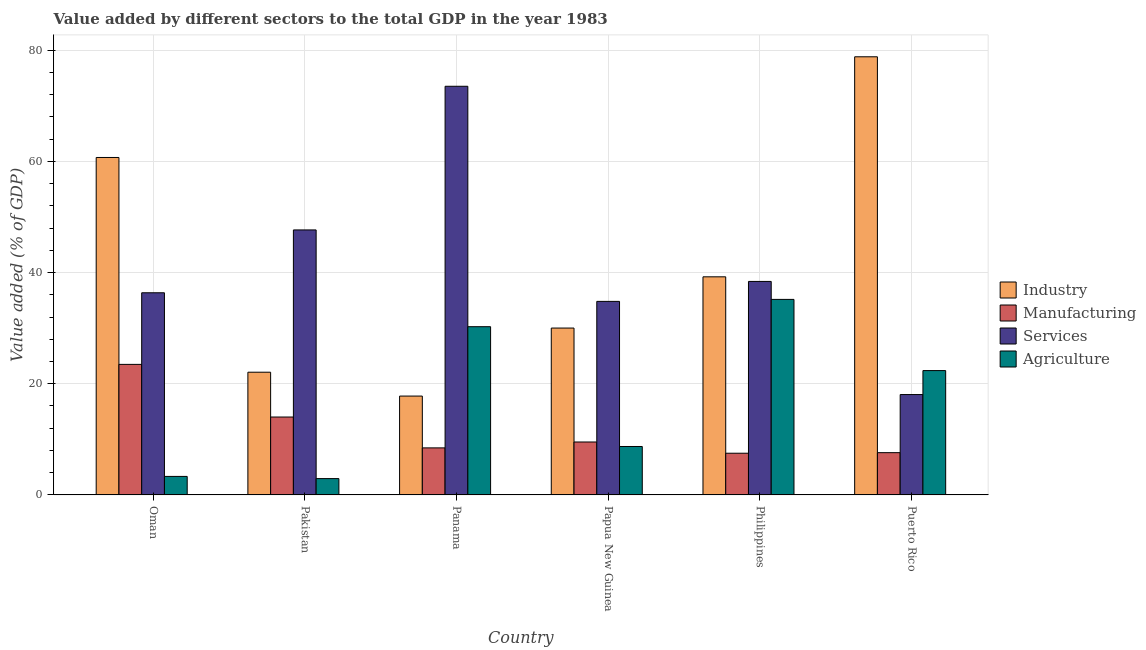How many different coloured bars are there?
Keep it short and to the point. 4. How many groups of bars are there?
Your answer should be very brief. 6. Are the number of bars per tick equal to the number of legend labels?
Your answer should be very brief. Yes. Are the number of bars on each tick of the X-axis equal?
Ensure brevity in your answer.  Yes. How many bars are there on the 2nd tick from the left?
Offer a very short reply. 4. How many bars are there on the 2nd tick from the right?
Provide a succinct answer. 4. What is the label of the 2nd group of bars from the left?
Give a very brief answer. Pakistan. In how many cases, is the number of bars for a given country not equal to the number of legend labels?
Your answer should be compact. 0. What is the value added by manufacturing sector in Puerto Rico?
Make the answer very short. 7.6. Across all countries, what is the maximum value added by services sector?
Your response must be concise. 73.5. Across all countries, what is the minimum value added by industrial sector?
Make the answer very short. 17.78. In which country was the value added by services sector maximum?
Offer a terse response. Panama. In which country was the value added by services sector minimum?
Your response must be concise. Puerto Rico. What is the total value added by agricultural sector in the graph?
Your answer should be very brief. 102.78. What is the difference between the value added by manufacturing sector in Oman and that in Philippines?
Your answer should be very brief. 15.98. What is the difference between the value added by services sector in Puerto Rico and the value added by manufacturing sector in Pakistan?
Give a very brief answer. 4.04. What is the average value added by industrial sector per country?
Your response must be concise. 41.44. What is the difference between the value added by manufacturing sector and value added by agricultural sector in Oman?
Your response must be concise. 20.15. In how many countries, is the value added by services sector greater than 12 %?
Your answer should be compact. 6. What is the ratio of the value added by agricultural sector in Pakistan to that in Panama?
Provide a short and direct response. 0.1. Is the difference between the value added by industrial sector in Pakistan and Panama greater than the difference between the value added by manufacturing sector in Pakistan and Panama?
Provide a short and direct response. No. What is the difference between the highest and the second highest value added by agricultural sector?
Your response must be concise. 4.91. What is the difference between the highest and the lowest value added by industrial sector?
Give a very brief answer. 61.03. In how many countries, is the value added by manufacturing sector greater than the average value added by manufacturing sector taken over all countries?
Your answer should be very brief. 2. What does the 1st bar from the left in Papua New Guinea represents?
Offer a very short reply. Industry. What does the 4th bar from the right in Papua New Guinea represents?
Make the answer very short. Industry. How many bars are there?
Provide a short and direct response. 24. How many countries are there in the graph?
Your answer should be compact. 6. What is the difference between two consecutive major ticks on the Y-axis?
Offer a terse response. 20. Does the graph contain any zero values?
Keep it short and to the point. No. Where does the legend appear in the graph?
Provide a succinct answer. Center right. What is the title of the graph?
Your answer should be very brief. Value added by different sectors to the total GDP in the year 1983. Does "Taxes on income" appear as one of the legend labels in the graph?
Ensure brevity in your answer.  No. What is the label or title of the Y-axis?
Provide a short and direct response. Value added (% of GDP). What is the Value added (% of GDP) in Industry in Oman?
Offer a very short reply. 60.7. What is the Value added (% of GDP) in Manufacturing in Oman?
Your answer should be very brief. 23.48. What is the Value added (% of GDP) in Services in Oman?
Provide a succinct answer. 36.36. What is the Value added (% of GDP) in Agriculture in Oman?
Make the answer very short. 3.33. What is the Value added (% of GDP) of Industry in Pakistan?
Offer a terse response. 22.07. What is the Value added (% of GDP) in Manufacturing in Pakistan?
Keep it short and to the point. 14.01. What is the Value added (% of GDP) in Services in Pakistan?
Provide a short and direct response. 47.67. What is the Value added (% of GDP) in Agriculture in Pakistan?
Give a very brief answer. 2.94. What is the Value added (% of GDP) in Industry in Panama?
Your answer should be very brief. 17.78. What is the Value added (% of GDP) in Manufacturing in Panama?
Provide a short and direct response. 8.46. What is the Value added (% of GDP) in Services in Panama?
Ensure brevity in your answer.  73.5. What is the Value added (% of GDP) of Agriculture in Panama?
Provide a short and direct response. 30.26. What is the Value added (% of GDP) in Industry in Papua New Guinea?
Make the answer very short. 30.02. What is the Value added (% of GDP) of Manufacturing in Papua New Guinea?
Ensure brevity in your answer.  9.52. What is the Value added (% of GDP) of Services in Papua New Guinea?
Offer a very short reply. 34.81. What is the Value added (% of GDP) in Agriculture in Papua New Guinea?
Ensure brevity in your answer.  8.71. What is the Value added (% of GDP) of Industry in Philippines?
Your response must be concise. 39.23. What is the Value added (% of GDP) in Manufacturing in Philippines?
Offer a terse response. 7.5. What is the Value added (% of GDP) in Services in Philippines?
Provide a succinct answer. 38.4. What is the Value added (% of GDP) in Agriculture in Philippines?
Your response must be concise. 35.17. What is the Value added (% of GDP) of Industry in Puerto Rico?
Ensure brevity in your answer.  78.81. What is the Value added (% of GDP) of Manufacturing in Puerto Rico?
Your answer should be very brief. 7.6. What is the Value added (% of GDP) in Services in Puerto Rico?
Provide a succinct answer. 18.06. What is the Value added (% of GDP) of Agriculture in Puerto Rico?
Your answer should be compact. 22.37. Across all countries, what is the maximum Value added (% of GDP) of Industry?
Ensure brevity in your answer.  78.81. Across all countries, what is the maximum Value added (% of GDP) in Manufacturing?
Offer a terse response. 23.48. Across all countries, what is the maximum Value added (% of GDP) of Services?
Offer a terse response. 73.5. Across all countries, what is the maximum Value added (% of GDP) of Agriculture?
Offer a terse response. 35.17. Across all countries, what is the minimum Value added (% of GDP) in Industry?
Offer a terse response. 17.78. Across all countries, what is the minimum Value added (% of GDP) of Manufacturing?
Offer a very short reply. 7.5. Across all countries, what is the minimum Value added (% of GDP) of Services?
Provide a short and direct response. 18.06. Across all countries, what is the minimum Value added (% of GDP) in Agriculture?
Your response must be concise. 2.94. What is the total Value added (% of GDP) in Industry in the graph?
Keep it short and to the point. 248.61. What is the total Value added (% of GDP) of Manufacturing in the graph?
Give a very brief answer. 70.58. What is the total Value added (% of GDP) of Services in the graph?
Make the answer very short. 248.8. What is the total Value added (% of GDP) of Agriculture in the graph?
Your answer should be compact. 102.78. What is the difference between the Value added (% of GDP) in Industry in Oman and that in Pakistan?
Ensure brevity in your answer.  38.63. What is the difference between the Value added (% of GDP) in Manufacturing in Oman and that in Pakistan?
Make the answer very short. 9.47. What is the difference between the Value added (% of GDP) in Services in Oman and that in Pakistan?
Your answer should be very brief. -11.3. What is the difference between the Value added (% of GDP) in Agriculture in Oman and that in Pakistan?
Provide a succinct answer. 0.39. What is the difference between the Value added (% of GDP) in Industry in Oman and that in Panama?
Provide a succinct answer. 42.92. What is the difference between the Value added (% of GDP) in Manufacturing in Oman and that in Panama?
Ensure brevity in your answer.  15.02. What is the difference between the Value added (% of GDP) of Services in Oman and that in Panama?
Your response must be concise. -37.14. What is the difference between the Value added (% of GDP) in Agriculture in Oman and that in Panama?
Offer a terse response. -26.93. What is the difference between the Value added (% of GDP) in Industry in Oman and that in Papua New Guinea?
Ensure brevity in your answer.  30.68. What is the difference between the Value added (% of GDP) of Manufacturing in Oman and that in Papua New Guinea?
Your response must be concise. 13.96. What is the difference between the Value added (% of GDP) in Services in Oman and that in Papua New Guinea?
Provide a succinct answer. 1.55. What is the difference between the Value added (% of GDP) in Agriculture in Oman and that in Papua New Guinea?
Your response must be concise. -5.38. What is the difference between the Value added (% of GDP) in Industry in Oman and that in Philippines?
Your response must be concise. 21.47. What is the difference between the Value added (% of GDP) in Manufacturing in Oman and that in Philippines?
Your response must be concise. 15.98. What is the difference between the Value added (% of GDP) of Services in Oman and that in Philippines?
Give a very brief answer. -2.04. What is the difference between the Value added (% of GDP) in Agriculture in Oman and that in Philippines?
Make the answer very short. -31.84. What is the difference between the Value added (% of GDP) in Industry in Oman and that in Puerto Rico?
Make the answer very short. -18.11. What is the difference between the Value added (% of GDP) in Manufacturing in Oman and that in Puerto Rico?
Provide a succinct answer. 15.88. What is the difference between the Value added (% of GDP) of Services in Oman and that in Puerto Rico?
Your response must be concise. 18.31. What is the difference between the Value added (% of GDP) of Agriculture in Oman and that in Puerto Rico?
Provide a succinct answer. -19.03. What is the difference between the Value added (% of GDP) of Industry in Pakistan and that in Panama?
Keep it short and to the point. 4.29. What is the difference between the Value added (% of GDP) of Manufacturing in Pakistan and that in Panama?
Your answer should be compact. 5.55. What is the difference between the Value added (% of GDP) of Services in Pakistan and that in Panama?
Your answer should be very brief. -25.84. What is the difference between the Value added (% of GDP) in Agriculture in Pakistan and that in Panama?
Make the answer very short. -27.32. What is the difference between the Value added (% of GDP) in Industry in Pakistan and that in Papua New Guinea?
Your response must be concise. -7.94. What is the difference between the Value added (% of GDP) in Manufacturing in Pakistan and that in Papua New Guinea?
Offer a terse response. 4.49. What is the difference between the Value added (% of GDP) of Services in Pakistan and that in Papua New Guinea?
Make the answer very short. 12.85. What is the difference between the Value added (% of GDP) in Agriculture in Pakistan and that in Papua New Guinea?
Provide a short and direct response. -5.77. What is the difference between the Value added (% of GDP) in Industry in Pakistan and that in Philippines?
Your response must be concise. -17.16. What is the difference between the Value added (% of GDP) of Manufacturing in Pakistan and that in Philippines?
Provide a short and direct response. 6.51. What is the difference between the Value added (% of GDP) in Services in Pakistan and that in Philippines?
Keep it short and to the point. 9.26. What is the difference between the Value added (% of GDP) in Agriculture in Pakistan and that in Philippines?
Keep it short and to the point. -32.23. What is the difference between the Value added (% of GDP) in Industry in Pakistan and that in Puerto Rico?
Offer a terse response. -56.74. What is the difference between the Value added (% of GDP) in Manufacturing in Pakistan and that in Puerto Rico?
Your answer should be very brief. 6.41. What is the difference between the Value added (% of GDP) in Services in Pakistan and that in Puerto Rico?
Your answer should be compact. 29.61. What is the difference between the Value added (% of GDP) in Agriculture in Pakistan and that in Puerto Rico?
Ensure brevity in your answer.  -19.43. What is the difference between the Value added (% of GDP) in Industry in Panama and that in Papua New Guinea?
Offer a terse response. -12.23. What is the difference between the Value added (% of GDP) of Manufacturing in Panama and that in Papua New Guinea?
Your answer should be very brief. -1.06. What is the difference between the Value added (% of GDP) in Services in Panama and that in Papua New Guinea?
Keep it short and to the point. 38.69. What is the difference between the Value added (% of GDP) of Agriculture in Panama and that in Papua New Guinea?
Provide a succinct answer. 21.55. What is the difference between the Value added (% of GDP) in Industry in Panama and that in Philippines?
Give a very brief answer. -21.45. What is the difference between the Value added (% of GDP) of Manufacturing in Panama and that in Philippines?
Provide a succinct answer. 0.96. What is the difference between the Value added (% of GDP) of Services in Panama and that in Philippines?
Offer a terse response. 35.1. What is the difference between the Value added (% of GDP) of Agriculture in Panama and that in Philippines?
Offer a very short reply. -4.91. What is the difference between the Value added (% of GDP) of Industry in Panama and that in Puerto Rico?
Your response must be concise. -61.03. What is the difference between the Value added (% of GDP) of Manufacturing in Panama and that in Puerto Rico?
Give a very brief answer. 0.86. What is the difference between the Value added (% of GDP) in Services in Panama and that in Puerto Rico?
Give a very brief answer. 55.45. What is the difference between the Value added (% of GDP) of Agriculture in Panama and that in Puerto Rico?
Keep it short and to the point. 7.9. What is the difference between the Value added (% of GDP) of Industry in Papua New Guinea and that in Philippines?
Offer a very short reply. -9.22. What is the difference between the Value added (% of GDP) of Manufacturing in Papua New Guinea and that in Philippines?
Ensure brevity in your answer.  2.02. What is the difference between the Value added (% of GDP) in Services in Papua New Guinea and that in Philippines?
Make the answer very short. -3.59. What is the difference between the Value added (% of GDP) of Agriculture in Papua New Guinea and that in Philippines?
Keep it short and to the point. -26.46. What is the difference between the Value added (% of GDP) in Industry in Papua New Guinea and that in Puerto Rico?
Your response must be concise. -48.79. What is the difference between the Value added (% of GDP) in Manufacturing in Papua New Guinea and that in Puerto Rico?
Your answer should be compact. 1.92. What is the difference between the Value added (% of GDP) of Services in Papua New Guinea and that in Puerto Rico?
Your answer should be compact. 16.76. What is the difference between the Value added (% of GDP) of Agriculture in Papua New Guinea and that in Puerto Rico?
Offer a very short reply. -13.65. What is the difference between the Value added (% of GDP) in Industry in Philippines and that in Puerto Rico?
Offer a terse response. -39.58. What is the difference between the Value added (% of GDP) of Manufacturing in Philippines and that in Puerto Rico?
Provide a short and direct response. -0.1. What is the difference between the Value added (% of GDP) of Services in Philippines and that in Puerto Rico?
Your response must be concise. 20.35. What is the difference between the Value added (% of GDP) in Agriculture in Philippines and that in Puerto Rico?
Make the answer very short. 12.81. What is the difference between the Value added (% of GDP) in Industry in Oman and the Value added (% of GDP) in Manufacturing in Pakistan?
Make the answer very short. 46.69. What is the difference between the Value added (% of GDP) in Industry in Oman and the Value added (% of GDP) in Services in Pakistan?
Give a very brief answer. 13.03. What is the difference between the Value added (% of GDP) in Industry in Oman and the Value added (% of GDP) in Agriculture in Pakistan?
Provide a short and direct response. 57.76. What is the difference between the Value added (% of GDP) of Manufacturing in Oman and the Value added (% of GDP) of Services in Pakistan?
Your answer should be compact. -24.18. What is the difference between the Value added (% of GDP) of Manufacturing in Oman and the Value added (% of GDP) of Agriculture in Pakistan?
Ensure brevity in your answer.  20.54. What is the difference between the Value added (% of GDP) of Services in Oman and the Value added (% of GDP) of Agriculture in Pakistan?
Your response must be concise. 33.42. What is the difference between the Value added (% of GDP) of Industry in Oman and the Value added (% of GDP) of Manufacturing in Panama?
Your answer should be compact. 52.24. What is the difference between the Value added (% of GDP) of Industry in Oman and the Value added (% of GDP) of Services in Panama?
Offer a terse response. -12.81. What is the difference between the Value added (% of GDP) in Industry in Oman and the Value added (% of GDP) in Agriculture in Panama?
Your response must be concise. 30.44. What is the difference between the Value added (% of GDP) in Manufacturing in Oman and the Value added (% of GDP) in Services in Panama?
Your answer should be very brief. -50.02. What is the difference between the Value added (% of GDP) in Manufacturing in Oman and the Value added (% of GDP) in Agriculture in Panama?
Provide a succinct answer. -6.78. What is the difference between the Value added (% of GDP) in Services in Oman and the Value added (% of GDP) in Agriculture in Panama?
Your answer should be very brief. 6.1. What is the difference between the Value added (% of GDP) of Industry in Oman and the Value added (% of GDP) of Manufacturing in Papua New Guinea?
Provide a succinct answer. 51.18. What is the difference between the Value added (% of GDP) in Industry in Oman and the Value added (% of GDP) in Services in Papua New Guinea?
Keep it short and to the point. 25.89. What is the difference between the Value added (% of GDP) in Industry in Oman and the Value added (% of GDP) in Agriculture in Papua New Guinea?
Ensure brevity in your answer.  51.99. What is the difference between the Value added (% of GDP) in Manufacturing in Oman and the Value added (% of GDP) in Services in Papua New Guinea?
Your answer should be compact. -11.33. What is the difference between the Value added (% of GDP) in Manufacturing in Oman and the Value added (% of GDP) in Agriculture in Papua New Guinea?
Ensure brevity in your answer.  14.77. What is the difference between the Value added (% of GDP) of Services in Oman and the Value added (% of GDP) of Agriculture in Papua New Guinea?
Ensure brevity in your answer.  27.65. What is the difference between the Value added (% of GDP) of Industry in Oman and the Value added (% of GDP) of Manufacturing in Philippines?
Your response must be concise. 53.2. What is the difference between the Value added (% of GDP) in Industry in Oman and the Value added (% of GDP) in Services in Philippines?
Provide a short and direct response. 22.3. What is the difference between the Value added (% of GDP) in Industry in Oman and the Value added (% of GDP) in Agriculture in Philippines?
Offer a terse response. 25.53. What is the difference between the Value added (% of GDP) of Manufacturing in Oman and the Value added (% of GDP) of Services in Philippines?
Provide a short and direct response. -14.92. What is the difference between the Value added (% of GDP) of Manufacturing in Oman and the Value added (% of GDP) of Agriculture in Philippines?
Provide a succinct answer. -11.69. What is the difference between the Value added (% of GDP) in Services in Oman and the Value added (% of GDP) in Agriculture in Philippines?
Offer a terse response. 1.19. What is the difference between the Value added (% of GDP) in Industry in Oman and the Value added (% of GDP) in Manufacturing in Puerto Rico?
Offer a very short reply. 53.1. What is the difference between the Value added (% of GDP) of Industry in Oman and the Value added (% of GDP) of Services in Puerto Rico?
Give a very brief answer. 42.64. What is the difference between the Value added (% of GDP) of Industry in Oman and the Value added (% of GDP) of Agriculture in Puerto Rico?
Offer a terse response. 38.33. What is the difference between the Value added (% of GDP) of Manufacturing in Oman and the Value added (% of GDP) of Services in Puerto Rico?
Offer a very short reply. 5.43. What is the difference between the Value added (% of GDP) of Manufacturing in Oman and the Value added (% of GDP) of Agriculture in Puerto Rico?
Give a very brief answer. 1.12. What is the difference between the Value added (% of GDP) in Services in Oman and the Value added (% of GDP) in Agriculture in Puerto Rico?
Your response must be concise. 14. What is the difference between the Value added (% of GDP) in Industry in Pakistan and the Value added (% of GDP) in Manufacturing in Panama?
Offer a terse response. 13.61. What is the difference between the Value added (% of GDP) of Industry in Pakistan and the Value added (% of GDP) of Services in Panama?
Provide a short and direct response. -51.43. What is the difference between the Value added (% of GDP) of Industry in Pakistan and the Value added (% of GDP) of Agriculture in Panama?
Provide a short and direct response. -8.19. What is the difference between the Value added (% of GDP) of Manufacturing in Pakistan and the Value added (% of GDP) of Services in Panama?
Your response must be concise. -59.49. What is the difference between the Value added (% of GDP) of Manufacturing in Pakistan and the Value added (% of GDP) of Agriculture in Panama?
Provide a short and direct response. -16.25. What is the difference between the Value added (% of GDP) of Services in Pakistan and the Value added (% of GDP) of Agriculture in Panama?
Offer a terse response. 17.41. What is the difference between the Value added (% of GDP) of Industry in Pakistan and the Value added (% of GDP) of Manufacturing in Papua New Guinea?
Your answer should be compact. 12.55. What is the difference between the Value added (% of GDP) in Industry in Pakistan and the Value added (% of GDP) in Services in Papua New Guinea?
Keep it short and to the point. -12.74. What is the difference between the Value added (% of GDP) of Industry in Pakistan and the Value added (% of GDP) of Agriculture in Papua New Guinea?
Your response must be concise. 13.36. What is the difference between the Value added (% of GDP) of Manufacturing in Pakistan and the Value added (% of GDP) of Services in Papua New Guinea?
Offer a terse response. -20.8. What is the difference between the Value added (% of GDP) of Manufacturing in Pakistan and the Value added (% of GDP) of Agriculture in Papua New Guinea?
Provide a short and direct response. 5.3. What is the difference between the Value added (% of GDP) in Services in Pakistan and the Value added (% of GDP) in Agriculture in Papua New Guinea?
Provide a short and direct response. 38.95. What is the difference between the Value added (% of GDP) of Industry in Pakistan and the Value added (% of GDP) of Manufacturing in Philippines?
Offer a very short reply. 14.57. What is the difference between the Value added (% of GDP) in Industry in Pakistan and the Value added (% of GDP) in Services in Philippines?
Offer a very short reply. -16.33. What is the difference between the Value added (% of GDP) in Industry in Pakistan and the Value added (% of GDP) in Agriculture in Philippines?
Ensure brevity in your answer.  -13.1. What is the difference between the Value added (% of GDP) of Manufacturing in Pakistan and the Value added (% of GDP) of Services in Philippines?
Ensure brevity in your answer.  -24.39. What is the difference between the Value added (% of GDP) of Manufacturing in Pakistan and the Value added (% of GDP) of Agriculture in Philippines?
Provide a short and direct response. -21.16. What is the difference between the Value added (% of GDP) of Services in Pakistan and the Value added (% of GDP) of Agriculture in Philippines?
Keep it short and to the point. 12.5. What is the difference between the Value added (% of GDP) of Industry in Pakistan and the Value added (% of GDP) of Manufacturing in Puerto Rico?
Your response must be concise. 14.47. What is the difference between the Value added (% of GDP) of Industry in Pakistan and the Value added (% of GDP) of Services in Puerto Rico?
Offer a terse response. 4.02. What is the difference between the Value added (% of GDP) in Industry in Pakistan and the Value added (% of GDP) in Agriculture in Puerto Rico?
Keep it short and to the point. -0.29. What is the difference between the Value added (% of GDP) in Manufacturing in Pakistan and the Value added (% of GDP) in Services in Puerto Rico?
Offer a very short reply. -4.04. What is the difference between the Value added (% of GDP) of Manufacturing in Pakistan and the Value added (% of GDP) of Agriculture in Puerto Rico?
Ensure brevity in your answer.  -8.35. What is the difference between the Value added (% of GDP) of Services in Pakistan and the Value added (% of GDP) of Agriculture in Puerto Rico?
Offer a terse response. 25.3. What is the difference between the Value added (% of GDP) of Industry in Panama and the Value added (% of GDP) of Manufacturing in Papua New Guinea?
Give a very brief answer. 8.26. What is the difference between the Value added (% of GDP) in Industry in Panama and the Value added (% of GDP) in Services in Papua New Guinea?
Give a very brief answer. -17.03. What is the difference between the Value added (% of GDP) in Industry in Panama and the Value added (% of GDP) in Agriculture in Papua New Guinea?
Ensure brevity in your answer.  9.07. What is the difference between the Value added (% of GDP) of Manufacturing in Panama and the Value added (% of GDP) of Services in Papua New Guinea?
Offer a very short reply. -26.35. What is the difference between the Value added (% of GDP) of Manufacturing in Panama and the Value added (% of GDP) of Agriculture in Papua New Guinea?
Ensure brevity in your answer.  -0.25. What is the difference between the Value added (% of GDP) of Services in Panama and the Value added (% of GDP) of Agriculture in Papua New Guinea?
Ensure brevity in your answer.  64.79. What is the difference between the Value added (% of GDP) in Industry in Panama and the Value added (% of GDP) in Manufacturing in Philippines?
Your response must be concise. 10.28. What is the difference between the Value added (% of GDP) in Industry in Panama and the Value added (% of GDP) in Services in Philippines?
Make the answer very short. -20.62. What is the difference between the Value added (% of GDP) in Industry in Panama and the Value added (% of GDP) in Agriculture in Philippines?
Provide a short and direct response. -17.39. What is the difference between the Value added (% of GDP) in Manufacturing in Panama and the Value added (% of GDP) in Services in Philippines?
Your answer should be very brief. -29.94. What is the difference between the Value added (% of GDP) in Manufacturing in Panama and the Value added (% of GDP) in Agriculture in Philippines?
Provide a short and direct response. -26.71. What is the difference between the Value added (% of GDP) in Services in Panama and the Value added (% of GDP) in Agriculture in Philippines?
Provide a short and direct response. 38.33. What is the difference between the Value added (% of GDP) of Industry in Panama and the Value added (% of GDP) of Manufacturing in Puerto Rico?
Provide a succinct answer. 10.18. What is the difference between the Value added (% of GDP) in Industry in Panama and the Value added (% of GDP) in Services in Puerto Rico?
Ensure brevity in your answer.  -0.27. What is the difference between the Value added (% of GDP) of Industry in Panama and the Value added (% of GDP) of Agriculture in Puerto Rico?
Make the answer very short. -4.58. What is the difference between the Value added (% of GDP) of Manufacturing in Panama and the Value added (% of GDP) of Services in Puerto Rico?
Your answer should be compact. -9.59. What is the difference between the Value added (% of GDP) of Manufacturing in Panama and the Value added (% of GDP) of Agriculture in Puerto Rico?
Make the answer very short. -13.9. What is the difference between the Value added (% of GDP) of Services in Panama and the Value added (% of GDP) of Agriculture in Puerto Rico?
Your response must be concise. 51.14. What is the difference between the Value added (% of GDP) in Industry in Papua New Guinea and the Value added (% of GDP) in Manufacturing in Philippines?
Provide a succinct answer. 22.51. What is the difference between the Value added (% of GDP) in Industry in Papua New Guinea and the Value added (% of GDP) in Services in Philippines?
Offer a terse response. -8.39. What is the difference between the Value added (% of GDP) of Industry in Papua New Guinea and the Value added (% of GDP) of Agriculture in Philippines?
Make the answer very short. -5.15. What is the difference between the Value added (% of GDP) of Manufacturing in Papua New Guinea and the Value added (% of GDP) of Services in Philippines?
Provide a short and direct response. -28.88. What is the difference between the Value added (% of GDP) in Manufacturing in Papua New Guinea and the Value added (% of GDP) in Agriculture in Philippines?
Make the answer very short. -25.65. What is the difference between the Value added (% of GDP) in Services in Papua New Guinea and the Value added (% of GDP) in Agriculture in Philippines?
Your response must be concise. -0.36. What is the difference between the Value added (% of GDP) of Industry in Papua New Guinea and the Value added (% of GDP) of Manufacturing in Puerto Rico?
Provide a short and direct response. 22.41. What is the difference between the Value added (% of GDP) in Industry in Papua New Guinea and the Value added (% of GDP) in Services in Puerto Rico?
Make the answer very short. 11.96. What is the difference between the Value added (% of GDP) of Industry in Papua New Guinea and the Value added (% of GDP) of Agriculture in Puerto Rico?
Your answer should be very brief. 7.65. What is the difference between the Value added (% of GDP) of Manufacturing in Papua New Guinea and the Value added (% of GDP) of Services in Puerto Rico?
Offer a very short reply. -8.53. What is the difference between the Value added (% of GDP) of Manufacturing in Papua New Guinea and the Value added (% of GDP) of Agriculture in Puerto Rico?
Give a very brief answer. -12.84. What is the difference between the Value added (% of GDP) of Services in Papua New Guinea and the Value added (% of GDP) of Agriculture in Puerto Rico?
Your answer should be very brief. 12.45. What is the difference between the Value added (% of GDP) in Industry in Philippines and the Value added (% of GDP) in Manufacturing in Puerto Rico?
Give a very brief answer. 31.63. What is the difference between the Value added (% of GDP) of Industry in Philippines and the Value added (% of GDP) of Services in Puerto Rico?
Offer a very short reply. 21.18. What is the difference between the Value added (% of GDP) in Industry in Philippines and the Value added (% of GDP) in Agriculture in Puerto Rico?
Offer a very short reply. 16.87. What is the difference between the Value added (% of GDP) of Manufacturing in Philippines and the Value added (% of GDP) of Services in Puerto Rico?
Your answer should be very brief. -10.55. What is the difference between the Value added (% of GDP) in Manufacturing in Philippines and the Value added (% of GDP) in Agriculture in Puerto Rico?
Ensure brevity in your answer.  -14.86. What is the difference between the Value added (% of GDP) in Services in Philippines and the Value added (% of GDP) in Agriculture in Puerto Rico?
Make the answer very short. 16.04. What is the average Value added (% of GDP) in Industry per country?
Provide a succinct answer. 41.44. What is the average Value added (% of GDP) of Manufacturing per country?
Your answer should be very brief. 11.76. What is the average Value added (% of GDP) of Services per country?
Make the answer very short. 41.47. What is the average Value added (% of GDP) in Agriculture per country?
Offer a terse response. 17.13. What is the difference between the Value added (% of GDP) of Industry and Value added (% of GDP) of Manufacturing in Oman?
Provide a short and direct response. 37.22. What is the difference between the Value added (% of GDP) of Industry and Value added (% of GDP) of Services in Oman?
Ensure brevity in your answer.  24.34. What is the difference between the Value added (% of GDP) in Industry and Value added (% of GDP) in Agriculture in Oman?
Make the answer very short. 57.37. What is the difference between the Value added (% of GDP) of Manufacturing and Value added (% of GDP) of Services in Oman?
Ensure brevity in your answer.  -12.88. What is the difference between the Value added (% of GDP) of Manufacturing and Value added (% of GDP) of Agriculture in Oman?
Keep it short and to the point. 20.15. What is the difference between the Value added (% of GDP) of Services and Value added (% of GDP) of Agriculture in Oman?
Offer a terse response. 33.03. What is the difference between the Value added (% of GDP) of Industry and Value added (% of GDP) of Manufacturing in Pakistan?
Provide a succinct answer. 8.06. What is the difference between the Value added (% of GDP) in Industry and Value added (% of GDP) in Services in Pakistan?
Offer a very short reply. -25.59. What is the difference between the Value added (% of GDP) in Industry and Value added (% of GDP) in Agriculture in Pakistan?
Your answer should be very brief. 19.14. What is the difference between the Value added (% of GDP) of Manufacturing and Value added (% of GDP) of Services in Pakistan?
Ensure brevity in your answer.  -33.65. What is the difference between the Value added (% of GDP) of Manufacturing and Value added (% of GDP) of Agriculture in Pakistan?
Give a very brief answer. 11.08. What is the difference between the Value added (% of GDP) of Services and Value added (% of GDP) of Agriculture in Pakistan?
Give a very brief answer. 44.73. What is the difference between the Value added (% of GDP) of Industry and Value added (% of GDP) of Manufacturing in Panama?
Provide a succinct answer. 9.32. What is the difference between the Value added (% of GDP) in Industry and Value added (% of GDP) in Services in Panama?
Offer a very short reply. -55.72. What is the difference between the Value added (% of GDP) in Industry and Value added (% of GDP) in Agriculture in Panama?
Your answer should be compact. -12.48. What is the difference between the Value added (% of GDP) of Manufacturing and Value added (% of GDP) of Services in Panama?
Offer a very short reply. -65.04. What is the difference between the Value added (% of GDP) in Manufacturing and Value added (% of GDP) in Agriculture in Panama?
Offer a terse response. -21.8. What is the difference between the Value added (% of GDP) of Services and Value added (% of GDP) of Agriculture in Panama?
Ensure brevity in your answer.  43.24. What is the difference between the Value added (% of GDP) in Industry and Value added (% of GDP) in Manufacturing in Papua New Guinea?
Keep it short and to the point. 20.49. What is the difference between the Value added (% of GDP) in Industry and Value added (% of GDP) in Services in Papua New Guinea?
Your answer should be compact. -4.8. What is the difference between the Value added (% of GDP) in Industry and Value added (% of GDP) in Agriculture in Papua New Guinea?
Your answer should be compact. 21.3. What is the difference between the Value added (% of GDP) of Manufacturing and Value added (% of GDP) of Services in Papua New Guinea?
Your response must be concise. -25.29. What is the difference between the Value added (% of GDP) of Manufacturing and Value added (% of GDP) of Agriculture in Papua New Guinea?
Your answer should be very brief. 0.81. What is the difference between the Value added (% of GDP) in Services and Value added (% of GDP) in Agriculture in Papua New Guinea?
Offer a very short reply. 26.1. What is the difference between the Value added (% of GDP) of Industry and Value added (% of GDP) of Manufacturing in Philippines?
Offer a very short reply. 31.73. What is the difference between the Value added (% of GDP) of Industry and Value added (% of GDP) of Services in Philippines?
Your answer should be very brief. 0.83. What is the difference between the Value added (% of GDP) of Industry and Value added (% of GDP) of Agriculture in Philippines?
Provide a short and direct response. 4.06. What is the difference between the Value added (% of GDP) in Manufacturing and Value added (% of GDP) in Services in Philippines?
Ensure brevity in your answer.  -30.9. What is the difference between the Value added (% of GDP) in Manufacturing and Value added (% of GDP) in Agriculture in Philippines?
Ensure brevity in your answer.  -27.67. What is the difference between the Value added (% of GDP) in Services and Value added (% of GDP) in Agriculture in Philippines?
Ensure brevity in your answer.  3.23. What is the difference between the Value added (% of GDP) of Industry and Value added (% of GDP) of Manufacturing in Puerto Rico?
Make the answer very short. 71.21. What is the difference between the Value added (% of GDP) in Industry and Value added (% of GDP) in Services in Puerto Rico?
Provide a succinct answer. 60.75. What is the difference between the Value added (% of GDP) in Industry and Value added (% of GDP) in Agriculture in Puerto Rico?
Give a very brief answer. 56.45. What is the difference between the Value added (% of GDP) in Manufacturing and Value added (% of GDP) in Services in Puerto Rico?
Give a very brief answer. -10.45. What is the difference between the Value added (% of GDP) of Manufacturing and Value added (% of GDP) of Agriculture in Puerto Rico?
Make the answer very short. -14.76. What is the difference between the Value added (% of GDP) of Services and Value added (% of GDP) of Agriculture in Puerto Rico?
Give a very brief answer. -4.31. What is the ratio of the Value added (% of GDP) in Industry in Oman to that in Pakistan?
Make the answer very short. 2.75. What is the ratio of the Value added (% of GDP) of Manufacturing in Oman to that in Pakistan?
Offer a very short reply. 1.68. What is the ratio of the Value added (% of GDP) of Services in Oman to that in Pakistan?
Provide a short and direct response. 0.76. What is the ratio of the Value added (% of GDP) in Agriculture in Oman to that in Pakistan?
Keep it short and to the point. 1.13. What is the ratio of the Value added (% of GDP) of Industry in Oman to that in Panama?
Offer a very short reply. 3.41. What is the ratio of the Value added (% of GDP) of Manufacturing in Oman to that in Panama?
Provide a succinct answer. 2.77. What is the ratio of the Value added (% of GDP) of Services in Oman to that in Panama?
Ensure brevity in your answer.  0.49. What is the ratio of the Value added (% of GDP) in Agriculture in Oman to that in Panama?
Make the answer very short. 0.11. What is the ratio of the Value added (% of GDP) in Industry in Oman to that in Papua New Guinea?
Your answer should be compact. 2.02. What is the ratio of the Value added (% of GDP) of Manufacturing in Oman to that in Papua New Guinea?
Provide a short and direct response. 2.47. What is the ratio of the Value added (% of GDP) of Services in Oman to that in Papua New Guinea?
Give a very brief answer. 1.04. What is the ratio of the Value added (% of GDP) in Agriculture in Oman to that in Papua New Guinea?
Offer a very short reply. 0.38. What is the ratio of the Value added (% of GDP) of Industry in Oman to that in Philippines?
Offer a very short reply. 1.55. What is the ratio of the Value added (% of GDP) in Manufacturing in Oman to that in Philippines?
Give a very brief answer. 3.13. What is the ratio of the Value added (% of GDP) of Services in Oman to that in Philippines?
Provide a succinct answer. 0.95. What is the ratio of the Value added (% of GDP) of Agriculture in Oman to that in Philippines?
Keep it short and to the point. 0.09. What is the ratio of the Value added (% of GDP) of Industry in Oman to that in Puerto Rico?
Your response must be concise. 0.77. What is the ratio of the Value added (% of GDP) of Manufacturing in Oman to that in Puerto Rico?
Make the answer very short. 3.09. What is the ratio of the Value added (% of GDP) in Services in Oman to that in Puerto Rico?
Provide a short and direct response. 2.01. What is the ratio of the Value added (% of GDP) in Agriculture in Oman to that in Puerto Rico?
Provide a short and direct response. 0.15. What is the ratio of the Value added (% of GDP) of Industry in Pakistan to that in Panama?
Provide a short and direct response. 1.24. What is the ratio of the Value added (% of GDP) of Manufacturing in Pakistan to that in Panama?
Offer a terse response. 1.66. What is the ratio of the Value added (% of GDP) of Services in Pakistan to that in Panama?
Your response must be concise. 0.65. What is the ratio of the Value added (% of GDP) of Agriculture in Pakistan to that in Panama?
Keep it short and to the point. 0.1. What is the ratio of the Value added (% of GDP) of Industry in Pakistan to that in Papua New Guinea?
Offer a terse response. 0.74. What is the ratio of the Value added (% of GDP) in Manufacturing in Pakistan to that in Papua New Guinea?
Offer a very short reply. 1.47. What is the ratio of the Value added (% of GDP) in Services in Pakistan to that in Papua New Guinea?
Give a very brief answer. 1.37. What is the ratio of the Value added (% of GDP) of Agriculture in Pakistan to that in Papua New Guinea?
Offer a very short reply. 0.34. What is the ratio of the Value added (% of GDP) of Industry in Pakistan to that in Philippines?
Make the answer very short. 0.56. What is the ratio of the Value added (% of GDP) of Manufacturing in Pakistan to that in Philippines?
Make the answer very short. 1.87. What is the ratio of the Value added (% of GDP) in Services in Pakistan to that in Philippines?
Provide a short and direct response. 1.24. What is the ratio of the Value added (% of GDP) in Agriculture in Pakistan to that in Philippines?
Your answer should be compact. 0.08. What is the ratio of the Value added (% of GDP) in Industry in Pakistan to that in Puerto Rico?
Offer a very short reply. 0.28. What is the ratio of the Value added (% of GDP) in Manufacturing in Pakistan to that in Puerto Rico?
Your answer should be very brief. 1.84. What is the ratio of the Value added (% of GDP) of Services in Pakistan to that in Puerto Rico?
Provide a succinct answer. 2.64. What is the ratio of the Value added (% of GDP) of Agriculture in Pakistan to that in Puerto Rico?
Offer a very short reply. 0.13. What is the ratio of the Value added (% of GDP) of Industry in Panama to that in Papua New Guinea?
Your response must be concise. 0.59. What is the ratio of the Value added (% of GDP) in Manufacturing in Panama to that in Papua New Guinea?
Give a very brief answer. 0.89. What is the ratio of the Value added (% of GDP) in Services in Panama to that in Papua New Guinea?
Ensure brevity in your answer.  2.11. What is the ratio of the Value added (% of GDP) in Agriculture in Panama to that in Papua New Guinea?
Ensure brevity in your answer.  3.47. What is the ratio of the Value added (% of GDP) of Industry in Panama to that in Philippines?
Offer a very short reply. 0.45. What is the ratio of the Value added (% of GDP) in Manufacturing in Panama to that in Philippines?
Keep it short and to the point. 1.13. What is the ratio of the Value added (% of GDP) of Services in Panama to that in Philippines?
Give a very brief answer. 1.91. What is the ratio of the Value added (% of GDP) of Agriculture in Panama to that in Philippines?
Your response must be concise. 0.86. What is the ratio of the Value added (% of GDP) in Industry in Panama to that in Puerto Rico?
Offer a terse response. 0.23. What is the ratio of the Value added (% of GDP) of Manufacturing in Panama to that in Puerto Rico?
Your response must be concise. 1.11. What is the ratio of the Value added (% of GDP) in Services in Panama to that in Puerto Rico?
Provide a succinct answer. 4.07. What is the ratio of the Value added (% of GDP) of Agriculture in Panama to that in Puerto Rico?
Give a very brief answer. 1.35. What is the ratio of the Value added (% of GDP) in Industry in Papua New Guinea to that in Philippines?
Offer a very short reply. 0.77. What is the ratio of the Value added (% of GDP) in Manufacturing in Papua New Guinea to that in Philippines?
Offer a terse response. 1.27. What is the ratio of the Value added (% of GDP) in Services in Papua New Guinea to that in Philippines?
Offer a terse response. 0.91. What is the ratio of the Value added (% of GDP) of Agriculture in Papua New Guinea to that in Philippines?
Ensure brevity in your answer.  0.25. What is the ratio of the Value added (% of GDP) of Industry in Papua New Guinea to that in Puerto Rico?
Provide a succinct answer. 0.38. What is the ratio of the Value added (% of GDP) of Manufacturing in Papua New Guinea to that in Puerto Rico?
Ensure brevity in your answer.  1.25. What is the ratio of the Value added (% of GDP) in Services in Papua New Guinea to that in Puerto Rico?
Your answer should be compact. 1.93. What is the ratio of the Value added (% of GDP) in Agriculture in Papua New Guinea to that in Puerto Rico?
Your response must be concise. 0.39. What is the ratio of the Value added (% of GDP) in Industry in Philippines to that in Puerto Rico?
Give a very brief answer. 0.5. What is the ratio of the Value added (% of GDP) of Services in Philippines to that in Puerto Rico?
Ensure brevity in your answer.  2.13. What is the ratio of the Value added (% of GDP) in Agriculture in Philippines to that in Puerto Rico?
Offer a terse response. 1.57. What is the difference between the highest and the second highest Value added (% of GDP) in Industry?
Offer a terse response. 18.11. What is the difference between the highest and the second highest Value added (% of GDP) in Manufacturing?
Your answer should be very brief. 9.47. What is the difference between the highest and the second highest Value added (% of GDP) in Services?
Ensure brevity in your answer.  25.84. What is the difference between the highest and the second highest Value added (% of GDP) of Agriculture?
Keep it short and to the point. 4.91. What is the difference between the highest and the lowest Value added (% of GDP) in Industry?
Your answer should be very brief. 61.03. What is the difference between the highest and the lowest Value added (% of GDP) in Manufacturing?
Offer a very short reply. 15.98. What is the difference between the highest and the lowest Value added (% of GDP) of Services?
Offer a terse response. 55.45. What is the difference between the highest and the lowest Value added (% of GDP) in Agriculture?
Provide a short and direct response. 32.23. 